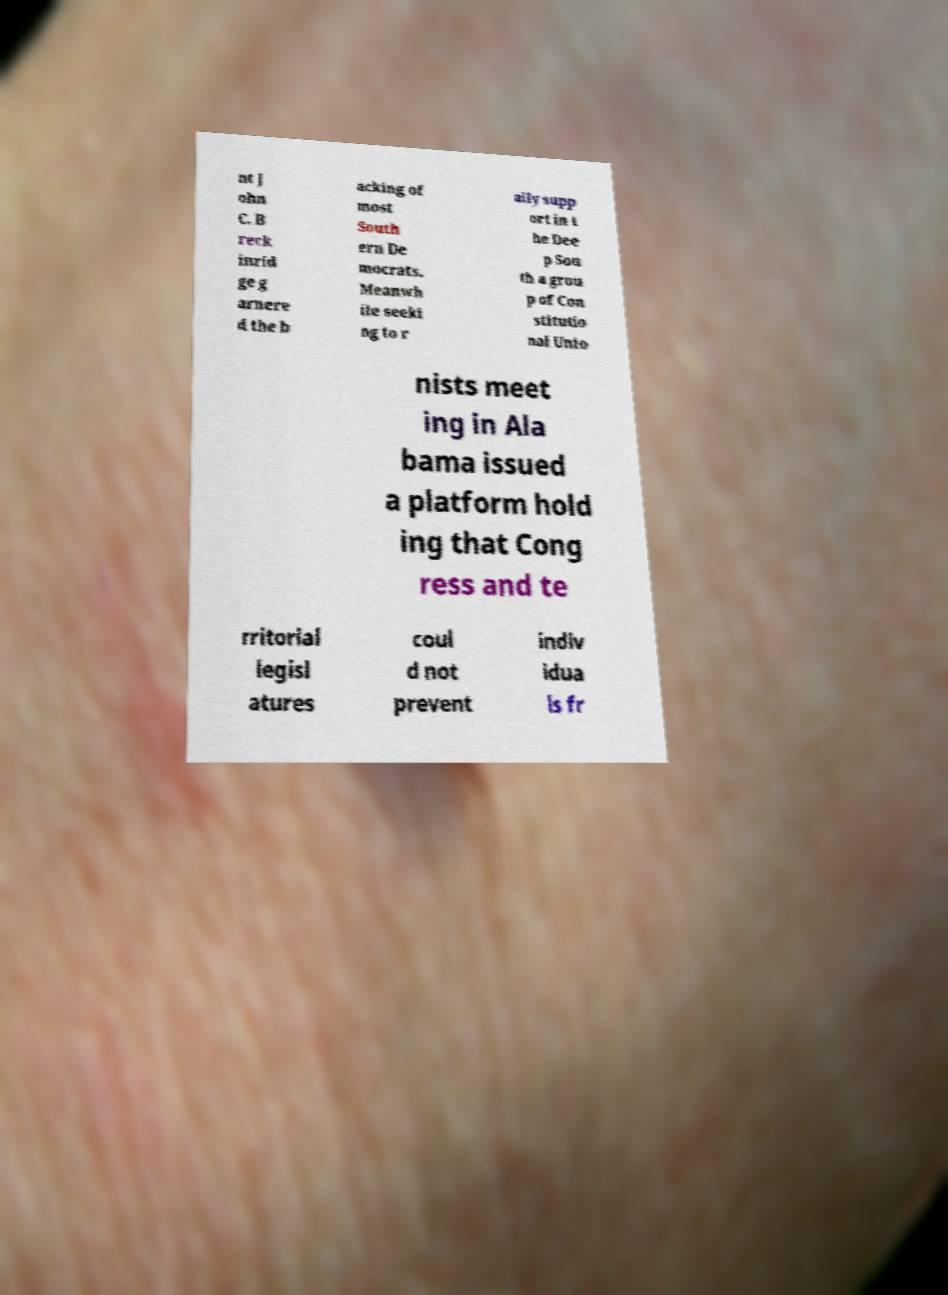Can you read and provide the text displayed in the image?This photo seems to have some interesting text. Can you extract and type it out for me? nt J ohn C. B reck inrid ge g arnere d the b acking of most South ern De mocrats. Meanwh ile seeki ng to r ally supp ort in t he Dee p Sou th a grou p of Con stitutio nal Unio nists meet ing in Ala bama issued a platform hold ing that Cong ress and te rritorial legisl atures coul d not prevent indiv idua ls fr 